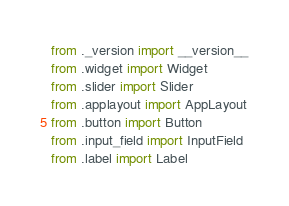<code> <loc_0><loc_0><loc_500><loc_500><_Python_>from ._version import __version__
from .widget import Widget
from .slider import Slider
from .applayout import AppLayout
from .button import Button
from .input_field import InputField
from .label import Label
</code> 